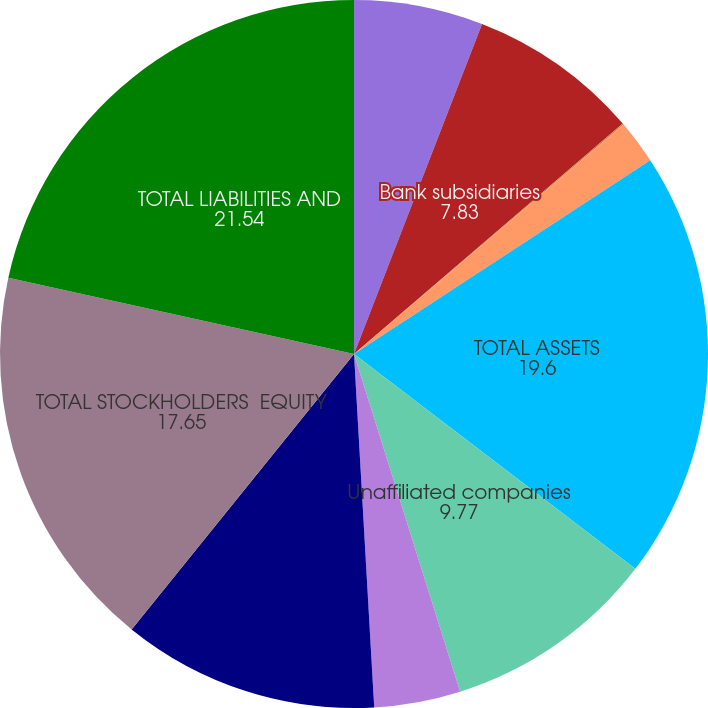Convert chart. <chart><loc_0><loc_0><loc_500><loc_500><pie_chart><fcel>Cash and due from banks<fcel>Bank subsidiaries<fcel>Nonbank subsidiaries<fcel>Other assets<fcel>TOTAL ASSETS<fcel>Unaffiliated companies<fcel>Other liabilities<fcel>TOTAL LIABILITIES<fcel>TOTAL STOCKHOLDERS EQUITY<fcel>TOTAL LIABILITIES AND<nl><fcel>5.89%<fcel>7.83%<fcel>0.06%<fcel>2.0%<fcel>19.6%<fcel>9.77%<fcel>3.94%<fcel>11.72%<fcel>17.65%<fcel>21.54%<nl></chart> 